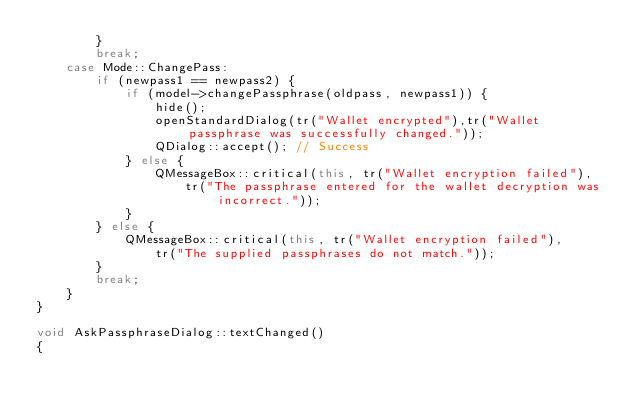Convert code to text. <code><loc_0><loc_0><loc_500><loc_500><_C++_>        }
        break;
    case Mode::ChangePass:
        if (newpass1 == newpass2) {
            if (model->changePassphrase(oldpass, newpass1)) {
                hide();
                openStandardDialog(tr("Wallet encrypted"),tr("Wallet passphrase was successfully changed."));
                QDialog::accept(); // Success
            } else {
                QMessageBox::critical(this, tr("Wallet encryption failed"),
                    tr("The passphrase entered for the wallet decryption was incorrect."));
            }
        } else {
            QMessageBox::critical(this, tr("Wallet encryption failed"),
                tr("The supplied passphrases do not match."));
        }
        break;
    }
}

void AskPassphraseDialog::textChanged()
{</code> 